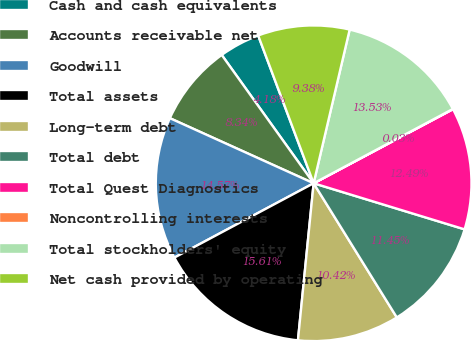Convert chart to OTSL. <chart><loc_0><loc_0><loc_500><loc_500><pie_chart><fcel>Cash and cash equivalents<fcel>Accounts receivable net<fcel>Goodwill<fcel>Total assets<fcel>Long-term debt<fcel>Total debt<fcel>Total Quest Diagnostics<fcel>Noncontrolling interests<fcel>Total stockholders' equity<fcel>Net cash provided by operating<nl><fcel>4.18%<fcel>8.34%<fcel>14.57%<fcel>15.61%<fcel>10.42%<fcel>11.45%<fcel>12.49%<fcel>0.03%<fcel>13.53%<fcel>9.38%<nl></chart> 